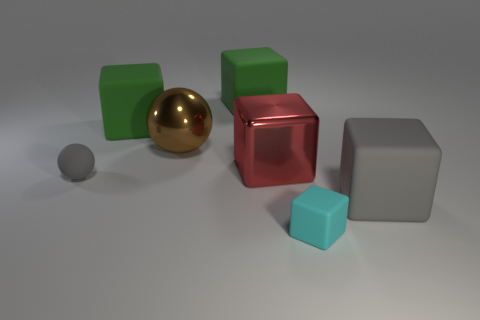Subtract all big metallic cubes. How many cubes are left? 4 Subtract all red blocks. How many blocks are left? 4 Subtract all blue cubes. Subtract all cyan cylinders. How many cubes are left? 5 Add 2 matte objects. How many objects exist? 9 Subtract all balls. How many objects are left? 5 Subtract 0 green cylinders. How many objects are left? 7 Subtract all tiny blue shiny cubes. Subtract all rubber things. How many objects are left? 2 Add 1 large brown metallic objects. How many large brown metallic objects are left? 2 Add 6 large red shiny objects. How many large red shiny objects exist? 7 